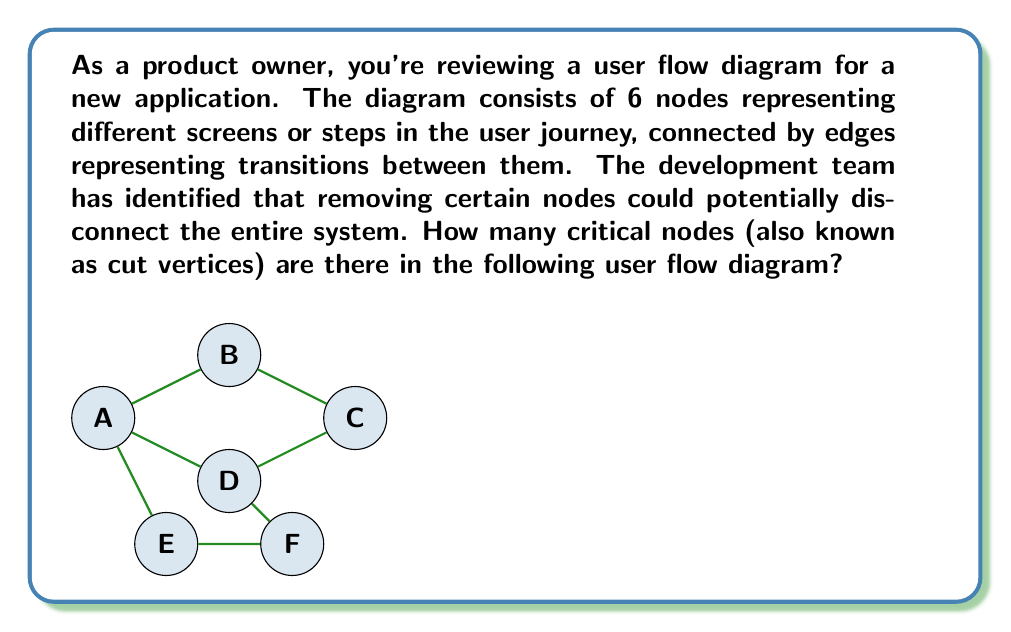What is the answer to this math problem? To solve this problem, we need to identify the cut vertices in the given graph. A cut vertex is a node that, when removed along with its incident edges, increases the number of connected components in the graph.

Let's analyze each node:

1. Node A: If removed, the graph remains connected. Not a cut vertex.
2. Node B: If removed, the graph remains connected. Not a cut vertex.
3. Node C: If removed, the graph remains connected. Not a cut vertex.
4. Node D: If removed, the graph is disconnected into two components: {A,B,C} and {E,F}. D is a cut vertex.
5. Node E: If removed, the graph remains connected. Not a cut vertex.
6. Node F: If removed, the graph remains connected. Not a cut vertex.

To verify this mathematically, we can use the following property:

For a vertex $v$ in a connected graph $G$, $v$ is a cut vertex if and only if there exist vertices $x$ and $y$ different from $v$ such that $v$ is on every path from $x$ to $y$.

In our case, for vertex D, we can choose E and C as $x$ and $y$. Every path from E to C must pass through D, confirming that D is indeed a cut vertex.

The identification of cut vertices is crucial in user flow diagrams as it highlights potential single points of failure in the system. In this case, node D represents a critical step in the user journey that, if removed, would disconnect the flow and potentially disrupt the user experience.
Answer: The user flow diagram contains 1 critical node (cut vertex), which is node D. 